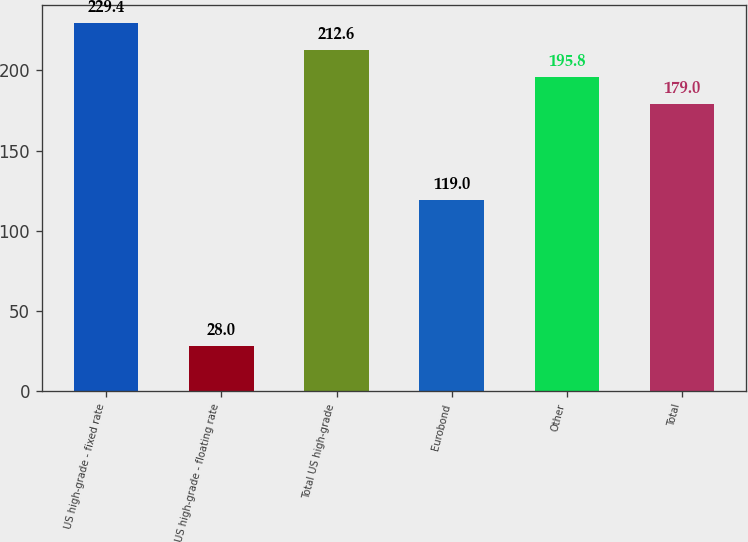Convert chart to OTSL. <chart><loc_0><loc_0><loc_500><loc_500><bar_chart><fcel>US high-grade - fixed rate<fcel>US high-grade - floating rate<fcel>Total US high-grade<fcel>Eurobond<fcel>Other<fcel>Total<nl><fcel>229.4<fcel>28<fcel>212.6<fcel>119<fcel>195.8<fcel>179<nl></chart> 